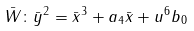Convert formula to latex. <formula><loc_0><loc_0><loc_500><loc_500>\bar { W } \colon \bar { y } ^ { 2 } = \bar { x } ^ { 3 } + a _ { 4 } \bar { x } + u ^ { 6 } b _ { 0 }</formula> 